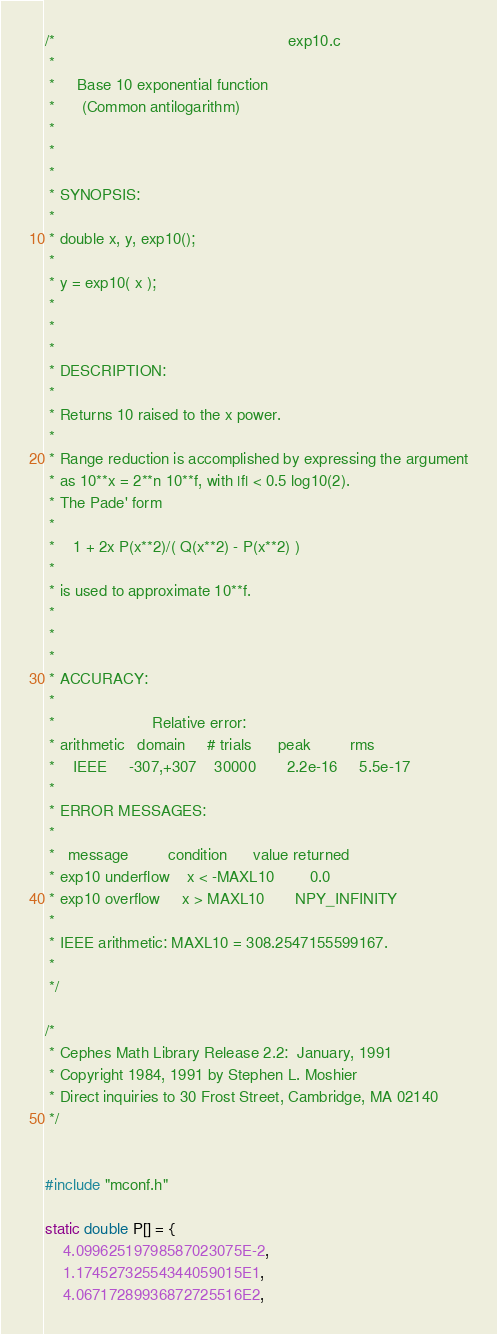<code> <loc_0><loc_0><loc_500><loc_500><_C_>/*                                                     exp10.c
 *
 *     Base 10 exponential function
 *      (Common antilogarithm)
 *
 *
 *
 * SYNOPSIS:
 *
 * double x, y, exp10();
 *
 * y = exp10( x );
 *
 *
 *
 * DESCRIPTION:
 *
 * Returns 10 raised to the x power.
 *
 * Range reduction is accomplished by expressing the argument
 * as 10**x = 2**n 10**f, with |f| < 0.5 log10(2).
 * The Pade' form
 *
 *    1 + 2x P(x**2)/( Q(x**2) - P(x**2) )
 *
 * is used to approximate 10**f.
 *
 *
 *
 * ACCURACY:
 *
 *                      Relative error:
 * arithmetic   domain     # trials      peak         rms
 *    IEEE     -307,+307    30000       2.2e-16     5.5e-17
 *
 * ERROR MESSAGES:
 *
 *   message         condition      value returned
 * exp10 underflow    x < -MAXL10        0.0
 * exp10 overflow     x > MAXL10       NPY_INFINITY
 *
 * IEEE arithmetic: MAXL10 = 308.2547155599167.
 *
 */

/*
 * Cephes Math Library Release 2.2:  January, 1991
 * Copyright 1984, 1991 by Stephen L. Moshier
 * Direct inquiries to 30 Frost Street, Cambridge, MA 02140
 */


#include "mconf.h"

static double P[] = {
    4.09962519798587023075E-2,
    1.17452732554344059015E1,
    4.06717289936872725516E2,</code> 